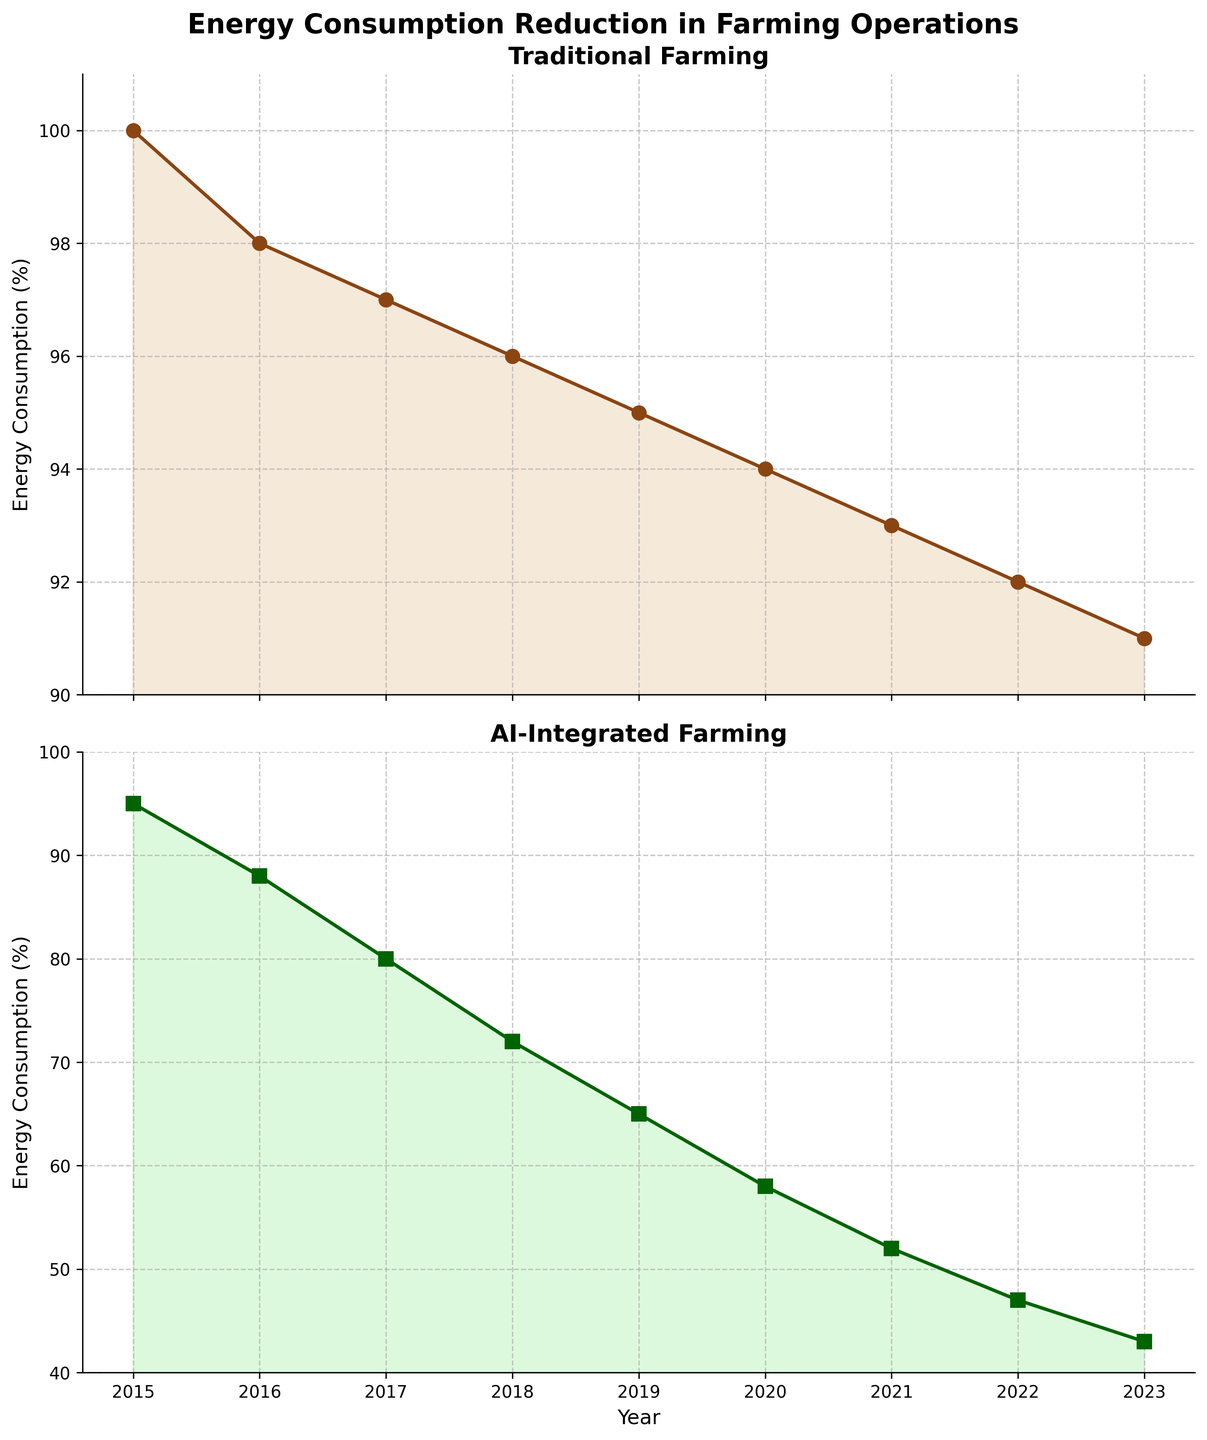What is the title of the figure? The title can be found at the top of the figure, written in a larger and bolder font compared to other text elements. The title states the main focus of the visualization.
Answer: "Energy Consumption Reduction in Farming Operations" What type of farming shows a greater reduction in energy consumption over time? We need to compare the slopes of the lines representing traditional and AI-integrated farming. The AI-integrated farming line has a steeper negative slope, indicating a greater reduction.
Answer: AI-Integrated Farming How much more energy consumption is reduced in 2023 compared to 2022 in AI-Integrated Farming? We need to subtract the AI-Integrated Farming value in 2023 (43%) from its value in 2022 (47%). 47 - 43 = 4%
Answer: 4% Between which consecutive years is the largest reduction in energy consumption for Traditional Farming observed? By observing the difference between year-to-year data points in the Traditional Farming line, the largest reduction is between 2015 (100%) and 2016 (98%). The difference is 2%.
Answer: Between 2015 and 2016 What is the difference in energy consumption between Traditional and AI-Integrated Farming in 2019? We find the energy consumption values for both farming types in 2019. Traditional Farming is at 95%, and AI-Integrated Farming is at 65%. The difference is 95 - 65 = 30%
Answer: 30% In which year did AI-Integrated Farming first reach an energy consumption below 50%? We look at the data points for AI-Integrated Farming across the years to find when the value first drops below 50%. It happens in 2021 (52 -> 47)
Answer: 2022 Which farming type shows a steady decline in terms of energy consumption reduction from 2015 to 2023? By examining the trend lines, Traditional Farming shows a more consistent and steady decline compared to AI-Integrated Farming, which drops more dramatically.
Answer: Traditional Farming What is the average energy consumption for AI-Integrated Farming from 2015 to 2023? Add all the percentages for AI-Integrated Farming and divide by the number of years. (95 + 88 + 80 + 72 + 65 + 58 + 52 + 47 + 43) / 9 = 66.67%
Answer: 66.67% How does the trend differ between Traditional and AI-Integrated Farming over the observed years? Traditional Farming shows a gradual decline in energy consumption, while AI-Integrated Farming shows a rapid decline. Analyzing the slopes and year-by-year reductions illustrates this difference.
Answer: Traditional is gradual, AI-Integrated is rapid 